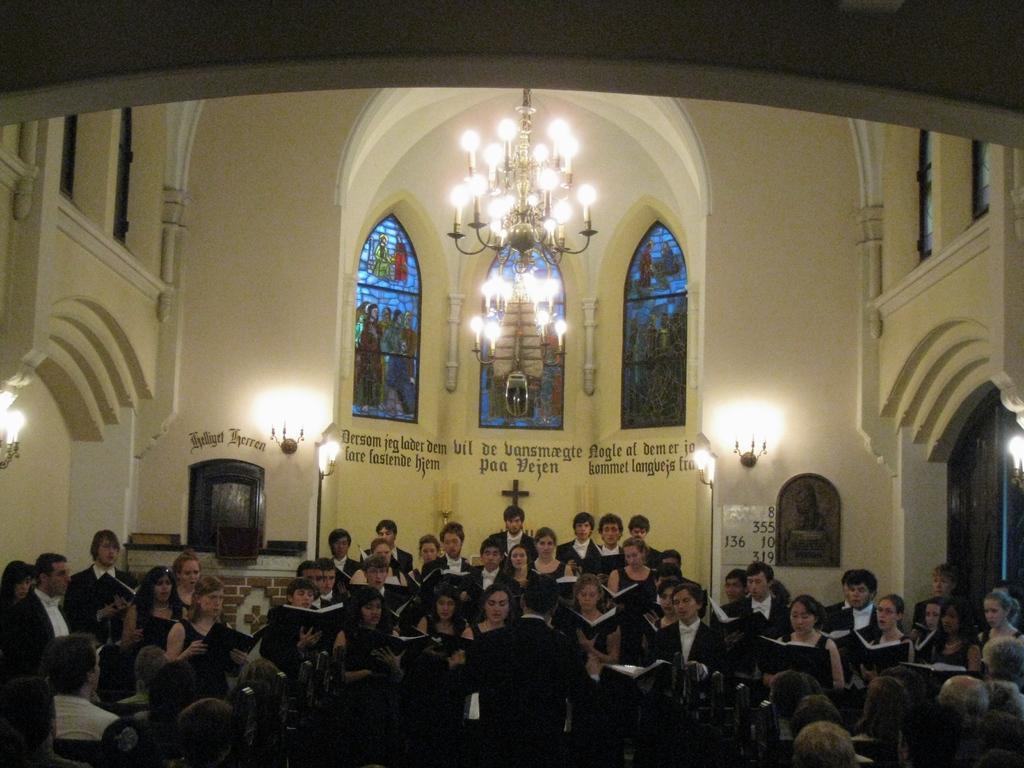Describe this image in one or two sentences. In the image I can see a cathedral construction. I can see a group of people and they are holding a book in their hands. I can see the decorative lamps on the wall. In the background, I can see the glass windows and there are paintings on the glass windows. There is a wooden door on the right side. 